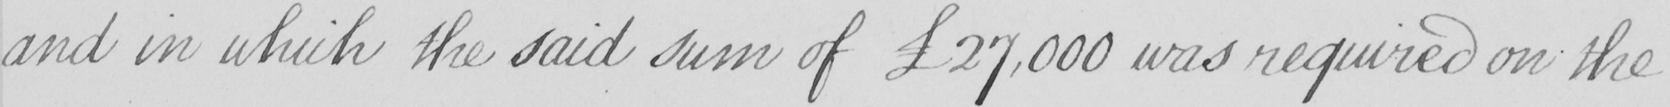What does this handwritten line say? and in which the said sum of  £27,000 was required on the 